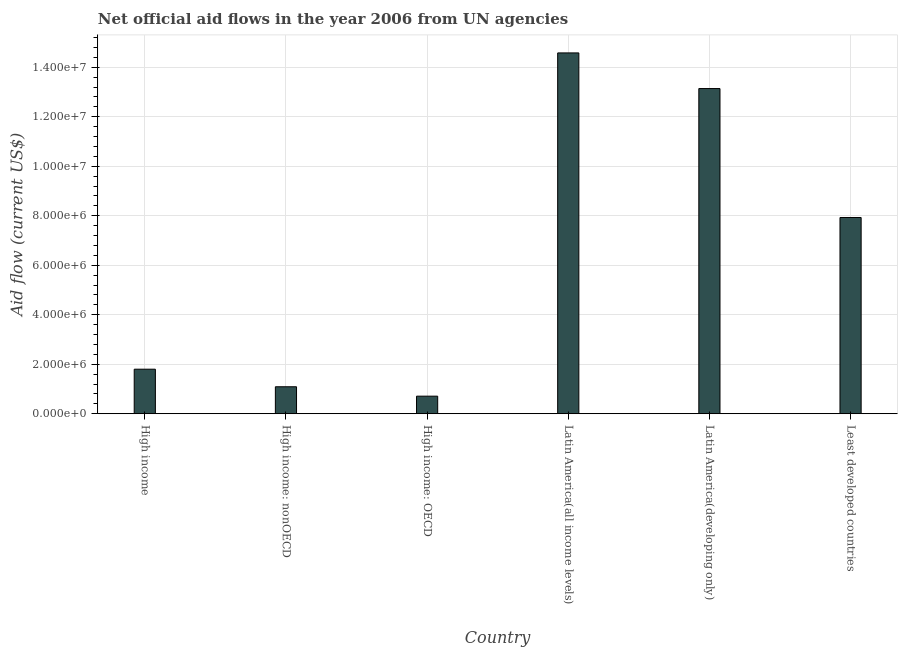Does the graph contain any zero values?
Make the answer very short. No. What is the title of the graph?
Your response must be concise. Net official aid flows in the year 2006 from UN agencies. What is the label or title of the X-axis?
Your answer should be very brief. Country. What is the net official flows from un agencies in High income?
Ensure brevity in your answer.  1.80e+06. Across all countries, what is the maximum net official flows from un agencies?
Give a very brief answer. 1.46e+07. Across all countries, what is the minimum net official flows from un agencies?
Your answer should be compact. 7.10e+05. In which country was the net official flows from un agencies maximum?
Give a very brief answer. Latin America(all income levels). In which country was the net official flows from un agencies minimum?
Offer a terse response. High income: OECD. What is the sum of the net official flows from un agencies?
Offer a terse response. 3.92e+07. What is the difference between the net official flows from un agencies in High income and High income: OECD?
Provide a short and direct response. 1.09e+06. What is the average net official flows from un agencies per country?
Your response must be concise. 6.54e+06. What is the median net official flows from un agencies?
Ensure brevity in your answer.  4.86e+06. What is the ratio of the net official flows from un agencies in High income to that in Latin America(developing only)?
Your response must be concise. 0.14. What is the difference between the highest and the second highest net official flows from un agencies?
Offer a very short reply. 1.44e+06. Is the sum of the net official flows from un agencies in High income: nonOECD and Latin America(all income levels) greater than the maximum net official flows from un agencies across all countries?
Offer a very short reply. Yes. What is the difference between the highest and the lowest net official flows from un agencies?
Your answer should be compact. 1.39e+07. In how many countries, is the net official flows from un agencies greater than the average net official flows from un agencies taken over all countries?
Keep it short and to the point. 3. Are all the bars in the graph horizontal?
Make the answer very short. No. How many countries are there in the graph?
Offer a terse response. 6. What is the difference between two consecutive major ticks on the Y-axis?
Your response must be concise. 2.00e+06. Are the values on the major ticks of Y-axis written in scientific E-notation?
Your answer should be compact. Yes. What is the Aid flow (current US$) of High income?
Offer a very short reply. 1.80e+06. What is the Aid flow (current US$) in High income: nonOECD?
Your response must be concise. 1.09e+06. What is the Aid flow (current US$) of High income: OECD?
Offer a terse response. 7.10e+05. What is the Aid flow (current US$) of Latin America(all income levels)?
Provide a succinct answer. 1.46e+07. What is the Aid flow (current US$) in Latin America(developing only)?
Your response must be concise. 1.31e+07. What is the Aid flow (current US$) of Least developed countries?
Make the answer very short. 7.93e+06. What is the difference between the Aid flow (current US$) in High income and High income: nonOECD?
Your answer should be very brief. 7.10e+05. What is the difference between the Aid flow (current US$) in High income and High income: OECD?
Keep it short and to the point. 1.09e+06. What is the difference between the Aid flow (current US$) in High income and Latin America(all income levels)?
Make the answer very short. -1.28e+07. What is the difference between the Aid flow (current US$) in High income and Latin America(developing only)?
Your answer should be compact. -1.13e+07. What is the difference between the Aid flow (current US$) in High income and Least developed countries?
Provide a short and direct response. -6.13e+06. What is the difference between the Aid flow (current US$) in High income: nonOECD and High income: OECD?
Provide a short and direct response. 3.80e+05. What is the difference between the Aid flow (current US$) in High income: nonOECD and Latin America(all income levels)?
Your answer should be very brief. -1.35e+07. What is the difference between the Aid flow (current US$) in High income: nonOECD and Latin America(developing only)?
Offer a very short reply. -1.20e+07. What is the difference between the Aid flow (current US$) in High income: nonOECD and Least developed countries?
Make the answer very short. -6.84e+06. What is the difference between the Aid flow (current US$) in High income: OECD and Latin America(all income levels)?
Offer a terse response. -1.39e+07. What is the difference between the Aid flow (current US$) in High income: OECD and Latin America(developing only)?
Make the answer very short. -1.24e+07. What is the difference between the Aid flow (current US$) in High income: OECD and Least developed countries?
Provide a succinct answer. -7.22e+06. What is the difference between the Aid flow (current US$) in Latin America(all income levels) and Latin America(developing only)?
Offer a terse response. 1.44e+06. What is the difference between the Aid flow (current US$) in Latin America(all income levels) and Least developed countries?
Offer a very short reply. 6.65e+06. What is the difference between the Aid flow (current US$) in Latin America(developing only) and Least developed countries?
Your response must be concise. 5.21e+06. What is the ratio of the Aid flow (current US$) in High income to that in High income: nonOECD?
Ensure brevity in your answer.  1.65. What is the ratio of the Aid flow (current US$) in High income to that in High income: OECD?
Give a very brief answer. 2.54. What is the ratio of the Aid flow (current US$) in High income to that in Latin America(all income levels)?
Offer a terse response. 0.12. What is the ratio of the Aid flow (current US$) in High income to that in Latin America(developing only)?
Your answer should be very brief. 0.14. What is the ratio of the Aid flow (current US$) in High income to that in Least developed countries?
Keep it short and to the point. 0.23. What is the ratio of the Aid flow (current US$) in High income: nonOECD to that in High income: OECD?
Provide a succinct answer. 1.53. What is the ratio of the Aid flow (current US$) in High income: nonOECD to that in Latin America(all income levels)?
Make the answer very short. 0.07. What is the ratio of the Aid flow (current US$) in High income: nonOECD to that in Latin America(developing only)?
Make the answer very short. 0.08. What is the ratio of the Aid flow (current US$) in High income: nonOECD to that in Least developed countries?
Keep it short and to the point. 0.14. What is the ratio of the Aid flow (current US$) in High income: OECD to that in Latin America(all income levels)?
Your answer should be very brief. 0.05. What is the ratio of the Aid flow (current US$) in High income: OECD to that in Latin America(developing only)?
Keep it short and to the point. 0.05. What is the ratio of the Aid flow (current US$) in High income: OECD to that in Least developed countries?
Ensure brevity in your answer.  0.09. What is the ratio of the Aid flow (current US$) in Latin America(all income levels) to that in Latin America(developing only)?
Keep it short and to the point. 1.11. What is the ratio of the Aid flow (current US$) in Latin America(all income levels) to that in Least developed countries?
Give a very brief answer. 1.84. What is the ratio of the Aid flow (current US$) in Latin America(developing only) to that in Least developed countries?
Your answer should be compact. 1.66. 